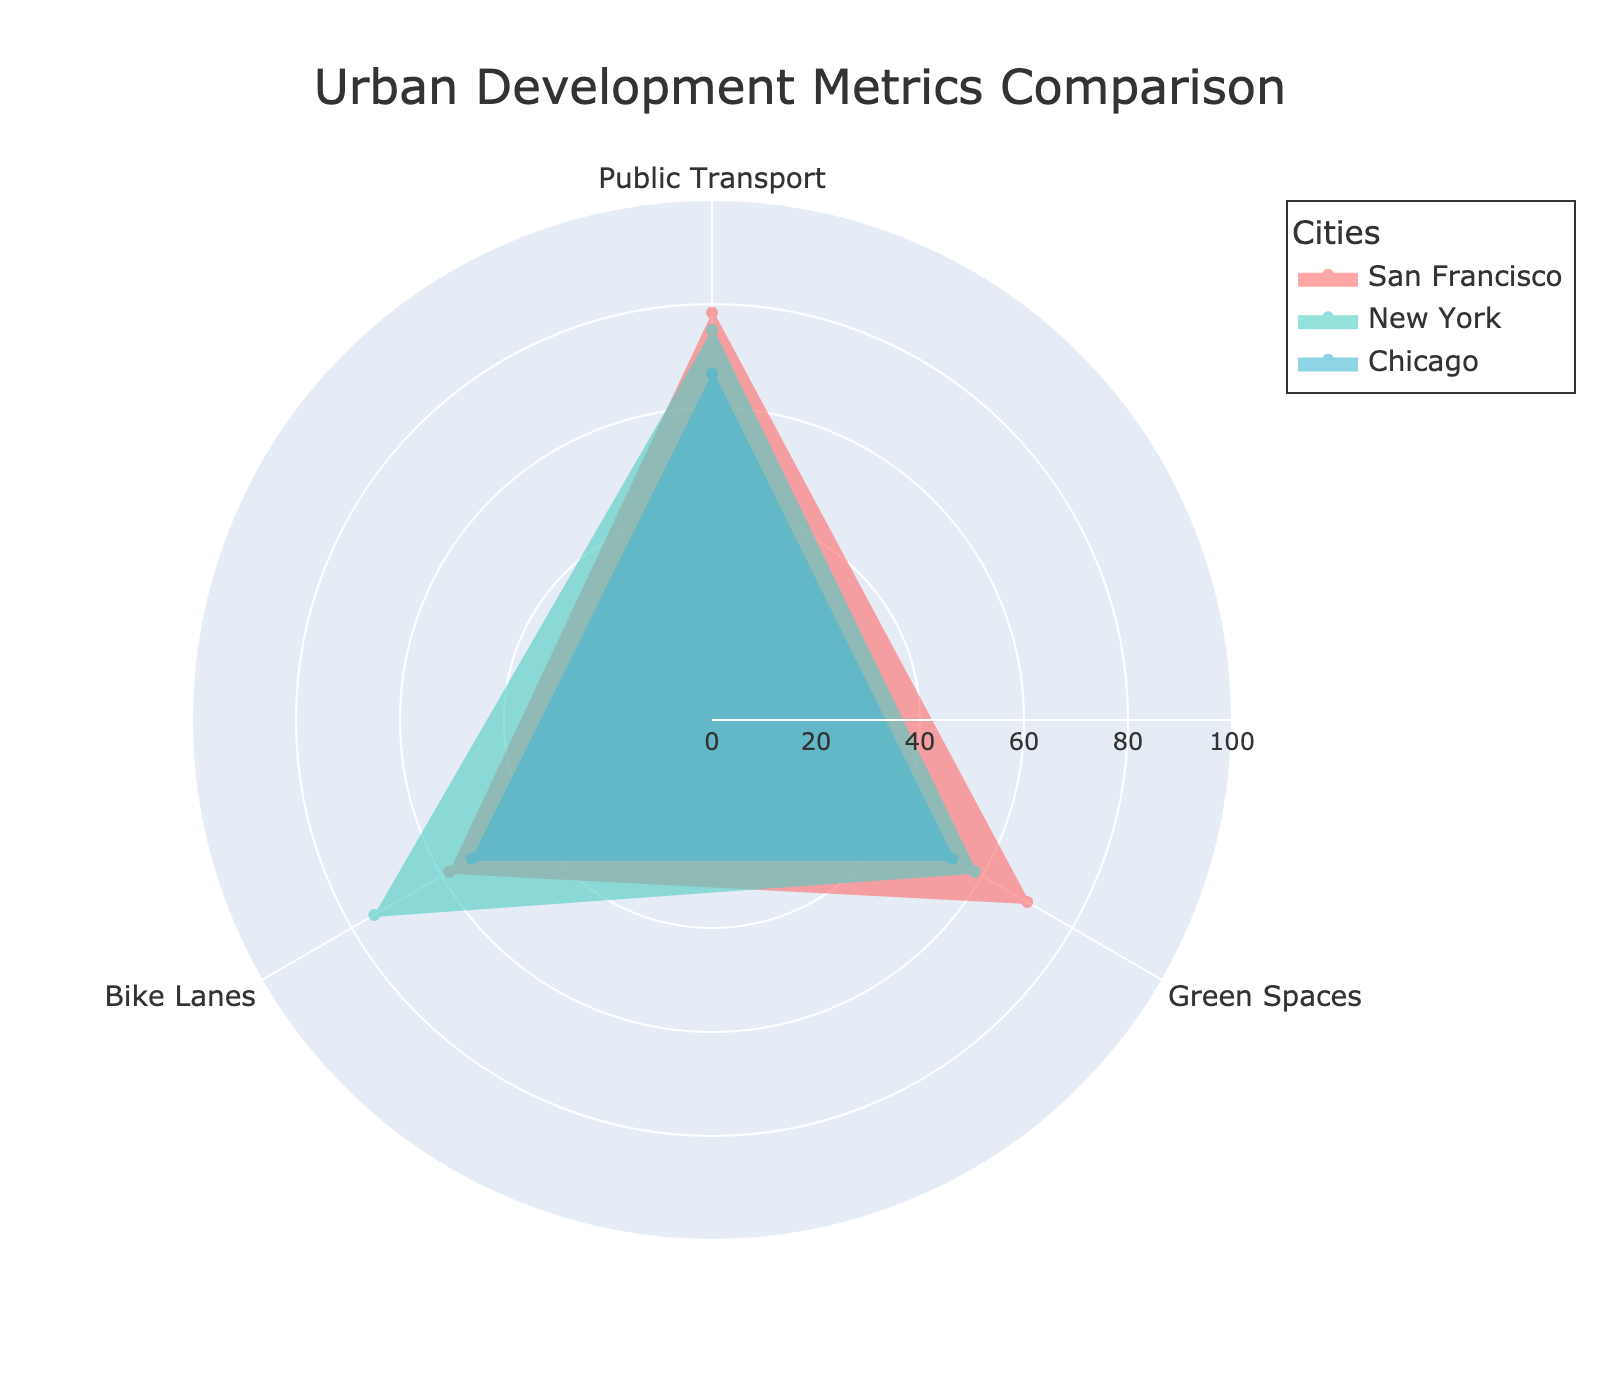What are the three metrics compared in the radar chart? You can see in the figure that each radar chart segment corresponds to a label. These labels conclude the three metrics compared: Public Transport, Green Spaces, and Bike Lanes.
Answer: Public Transport, Green Spaces, Bike Lanes What city has the highest average value for Green Spaces? To determine the city with the highest average value, check the green spaces component on each city's radar chart and compare them. The city with the highest average value is noticeable because its corresponding point is further out on the green spaces axis.
Answer: Richmond District Which city overall has the lowest accessibility on all three metrics combined? Evaluate the inner-boundaries for the data of each city in the radar chart. The city with the inner-most boundaries, on average, corresponds to the one with the lowest accessibility.
Answer: Chicago On average, which city has the best access to public transportation? Look at the public transportation points on each city segment. The city whose point is further towards the outer rings on the radar chart has the best access.
Answer: San Francisco Which city shows a balance between all three attributes? Identify the city whose radar chart is reasonably symmetric, indicating balanced values across all three attributes.
Answer: Boston What is the difference in access to bike lanes between San Francisco and Chicago? Find the bike lanes points for both San Francisco and Chicago. Compute the difference between the two values.
Answer: 15 (65 - 50) Which city has the lowest average value for green spaces? Check the green spaces segment for each city in the radar chart. The city with the innermost point on this segment has the lowest average value for green spaces.
Answer: New York What's the average access score to public transportation, green spaces, and bike lanes for New York? Calculate the mean values of New York’s three metrics from their corresponding points on the radar chart.
Answer: Access to Public Transport: 75, Green Spaces: 58.33, Bike Lanes: 75 